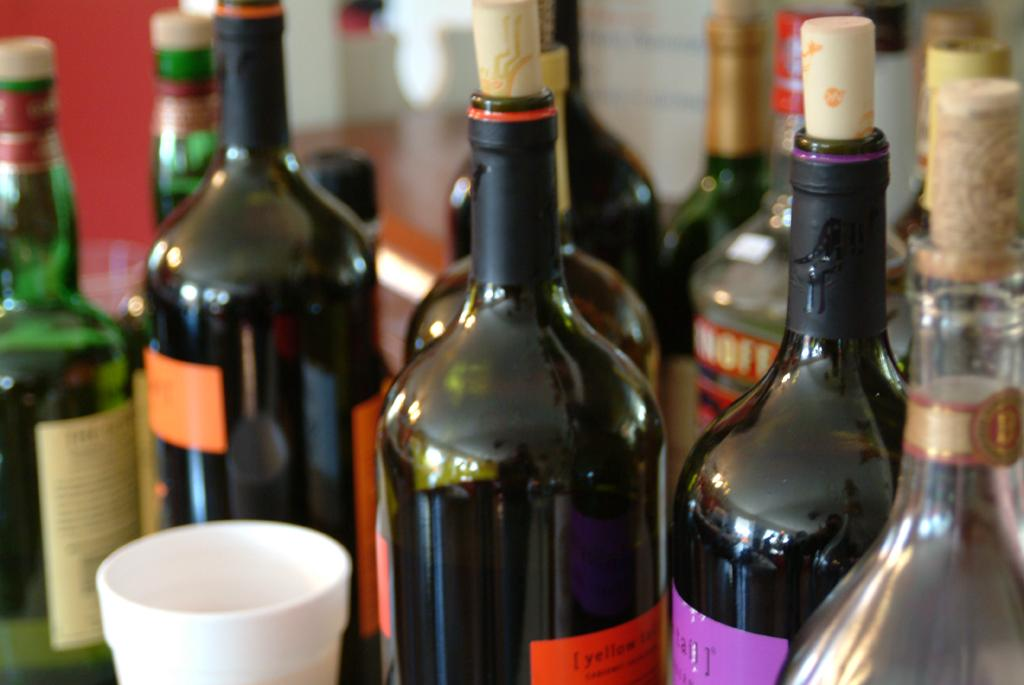What is the main subject of the image? The main subject of the image is many wine bottles. Where are the wine bottles located in the image? The wine bottles are placed on a table. What type of scene is depicted in the image involving an owl and glue? There is no scene involving an owl or glue present in the image; it only features wine bottles on a table. 